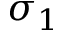Convert formula to latex. <formula><loc_0><loc_0><loc_500><loc_500>\sigma _ { 1 }</formula> 